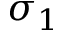Convert formula to latex. <formula><loc_0><loc_0><loc_500><loc_500>\sigma _ { 1 }</formula> 